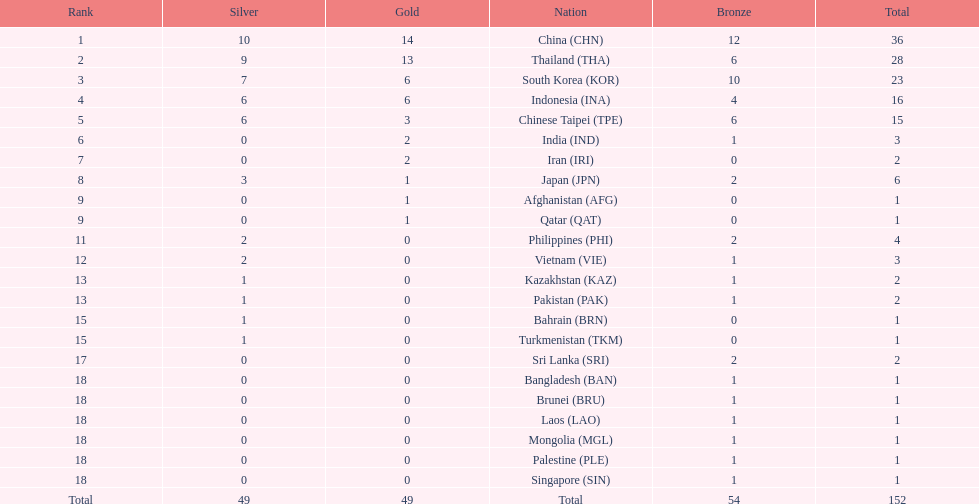Did the philippines or kazakhstan have a higher number of total medals? Philippines. 